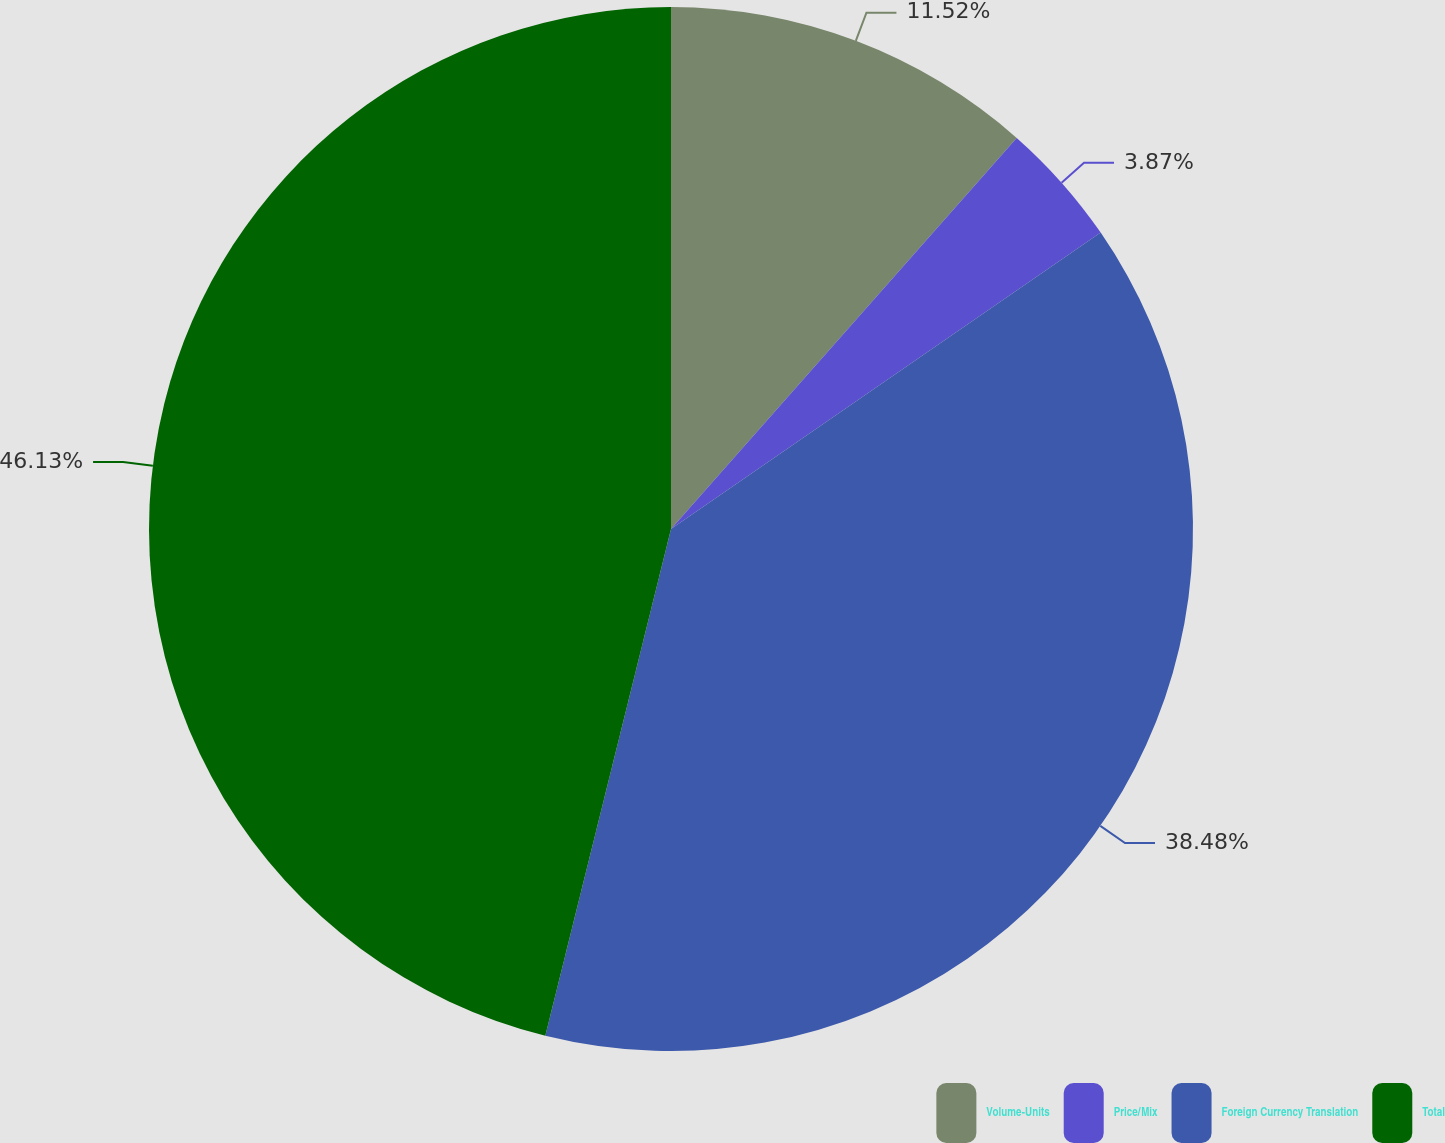Convert chart to OTSL. <chart><loc_0><loc_0><loc_500><loc_500><pie_chart><fcel>Volume-Units<fcel>Price/Mix<fcel>Foreign Currency Translation<fcel>Total<nl><fcel>11.52%<fcel>3.87%<fcel>38.48%<fcel>46.13%<nl></chart> 